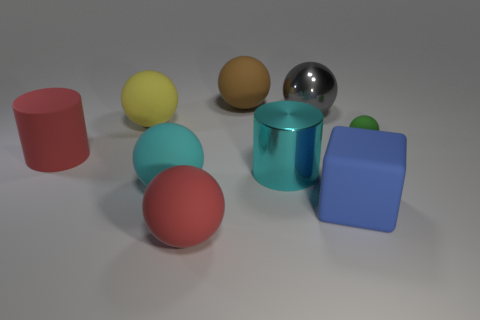Is the number of large cyan cylinders behind the large gray thing greater than the number of things that are right of the green rubber thing?
Your answer should be very brief. No. What material is the cyan cylinder that is the same size as the brown matte thing?
Your answer should be compact. Metal. How many small things are either yellow rubber balls or red matte cylinders?
Your answer should be compact. 0. Is the big blue thing the same shape as the tiny matte object?
Make the answer very short. No. What number of large matte objects are on the right side of the yellow rubber object and behind the cyan metal cylinder?
Your answer should be compact. 1. Is there anything else of the same color as the metal ball?
Make the answer very short. No. There is a large blue thing that is made of the same material as the tiny sphere; what shape is it?
Offer a very short reply. Cube. Is the cyan matte thing the same size as the yellow matte object?
Your response must be concise. Yes. Does the ball that is behind the large gray metallic thing have the same material as the tiny green object?
Provide a succinct answer. Yes. Is there anything else that is the same material as the large cyan ball?
Your answer should be compact. Yes. 